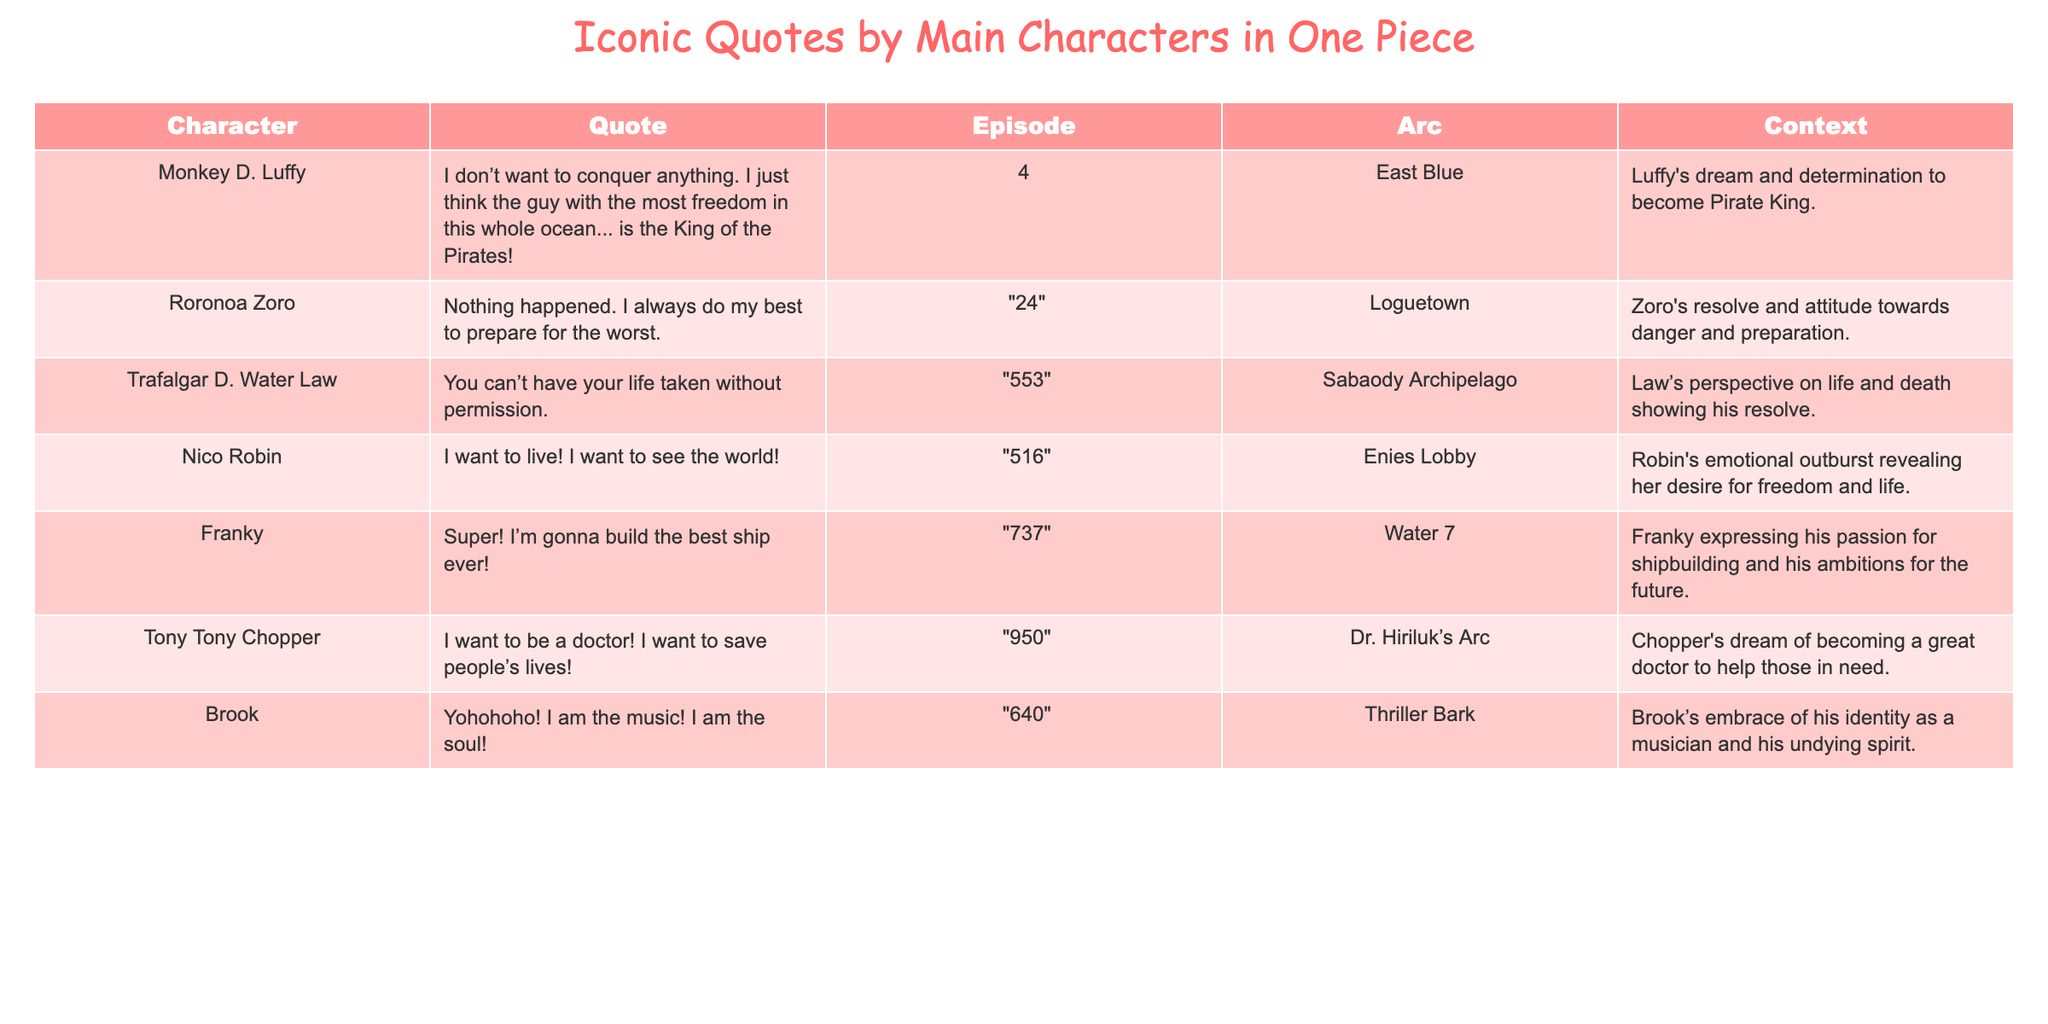What is the quote by Monkey D. Luffy? The table shows that Monkey D. Luffy's quote is "I don’t want to conquer anything. I just think the guy with the most freedom in this whole ocean... is the King of the Pirates!"
Answer: "I don’t want to conquer anything. I just think the guy with the most freedom in this whole ocean... is the King of the Pirates!" In which episode does Trafalgar D. Water Law say his iconic quote? According to the table, Trafalgar D. Water Law's quote is found in episode 553.
Answer: 553 What is Tony Tony Chopper's dream? The table indicates Tony Tony Chopper's dream is to be a doctor and to save people’s lives.
Answer: To be a doctor and save people's lives Which character's quote is associated with the Enies Lobby arc? The table states that Nico Robin's quote is associated with the Enies Lobby arc.
Answer: Nico Robin How many characters have quotes in the East Blue arc? The table shows that 1 character, Monkey D. Luffy, has a quote in the East Blue arc.
Answer: 1 Is Franky's quote about building ships? The table confirms that Franky's quote expresses his ambition to build the best ship.
Answer: Yes What is the context of Zoro's quote? According to the table, Zoro's quote is about his resolve and attitude towards danger and preparation.
Answer: His resolve and attitude towards danger Which character has an iconic quote expressing a desire for life and freedom? The table indicates that Nico Robin expresses a desire for life and freedom in her quote.
Answer: Nico Robin Count the total number of quotes from characters in the Sabaody Archipelago arc. The table shows that there is 1 quote from a character (Trafalgar D. Water Law) in the Sabaody Archipelago arc.
Answer: 1 What quote from Brook reflects his identity? The table indicates Brook's quote is "Yohohoho! I am the music! I am the soul!" which reflects his identity.
Answer: "Yohohoho! I am the music! I am the soul!" 